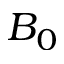<formula> <loc_0><loc_0><loc_500><loc_500>B _ { 0 }</formula> 